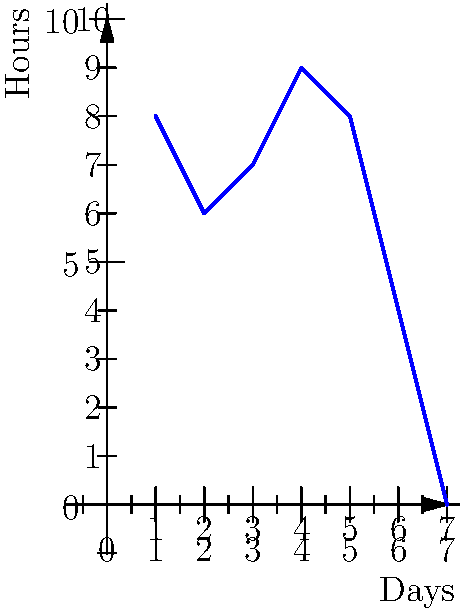As a small business owner, you're tracking the work hours of an employee over a week. The graph shows the daily hours worked from Monday (Day 1) to Sunday (Day 7). What is the total number of hours worked during the weekdays (Monday to Friday)? To solve this problem, we need to follow these steps:

1. Identify the weekdays on the graph (Days 1-5, representing Monday to Friday).
2. Read the number of hours worked for each weekday:
   - Day 1 (Monday): 8 hours
   - Day 2 (Tuesday): 6 hours
   - Day 3 (Wednesday): 7 hours
   - Day 4 (Thursday): 9 hours
   - Day 5 (Friday): 8 hours
3. Sum up the hours worked for these five days:
   $$ 8 + 6 + 7 + 9 + 8 = 38 $$

Therefore, the total number of hours worked during the weekdays is 38 hours.
Answer: 38 hours 